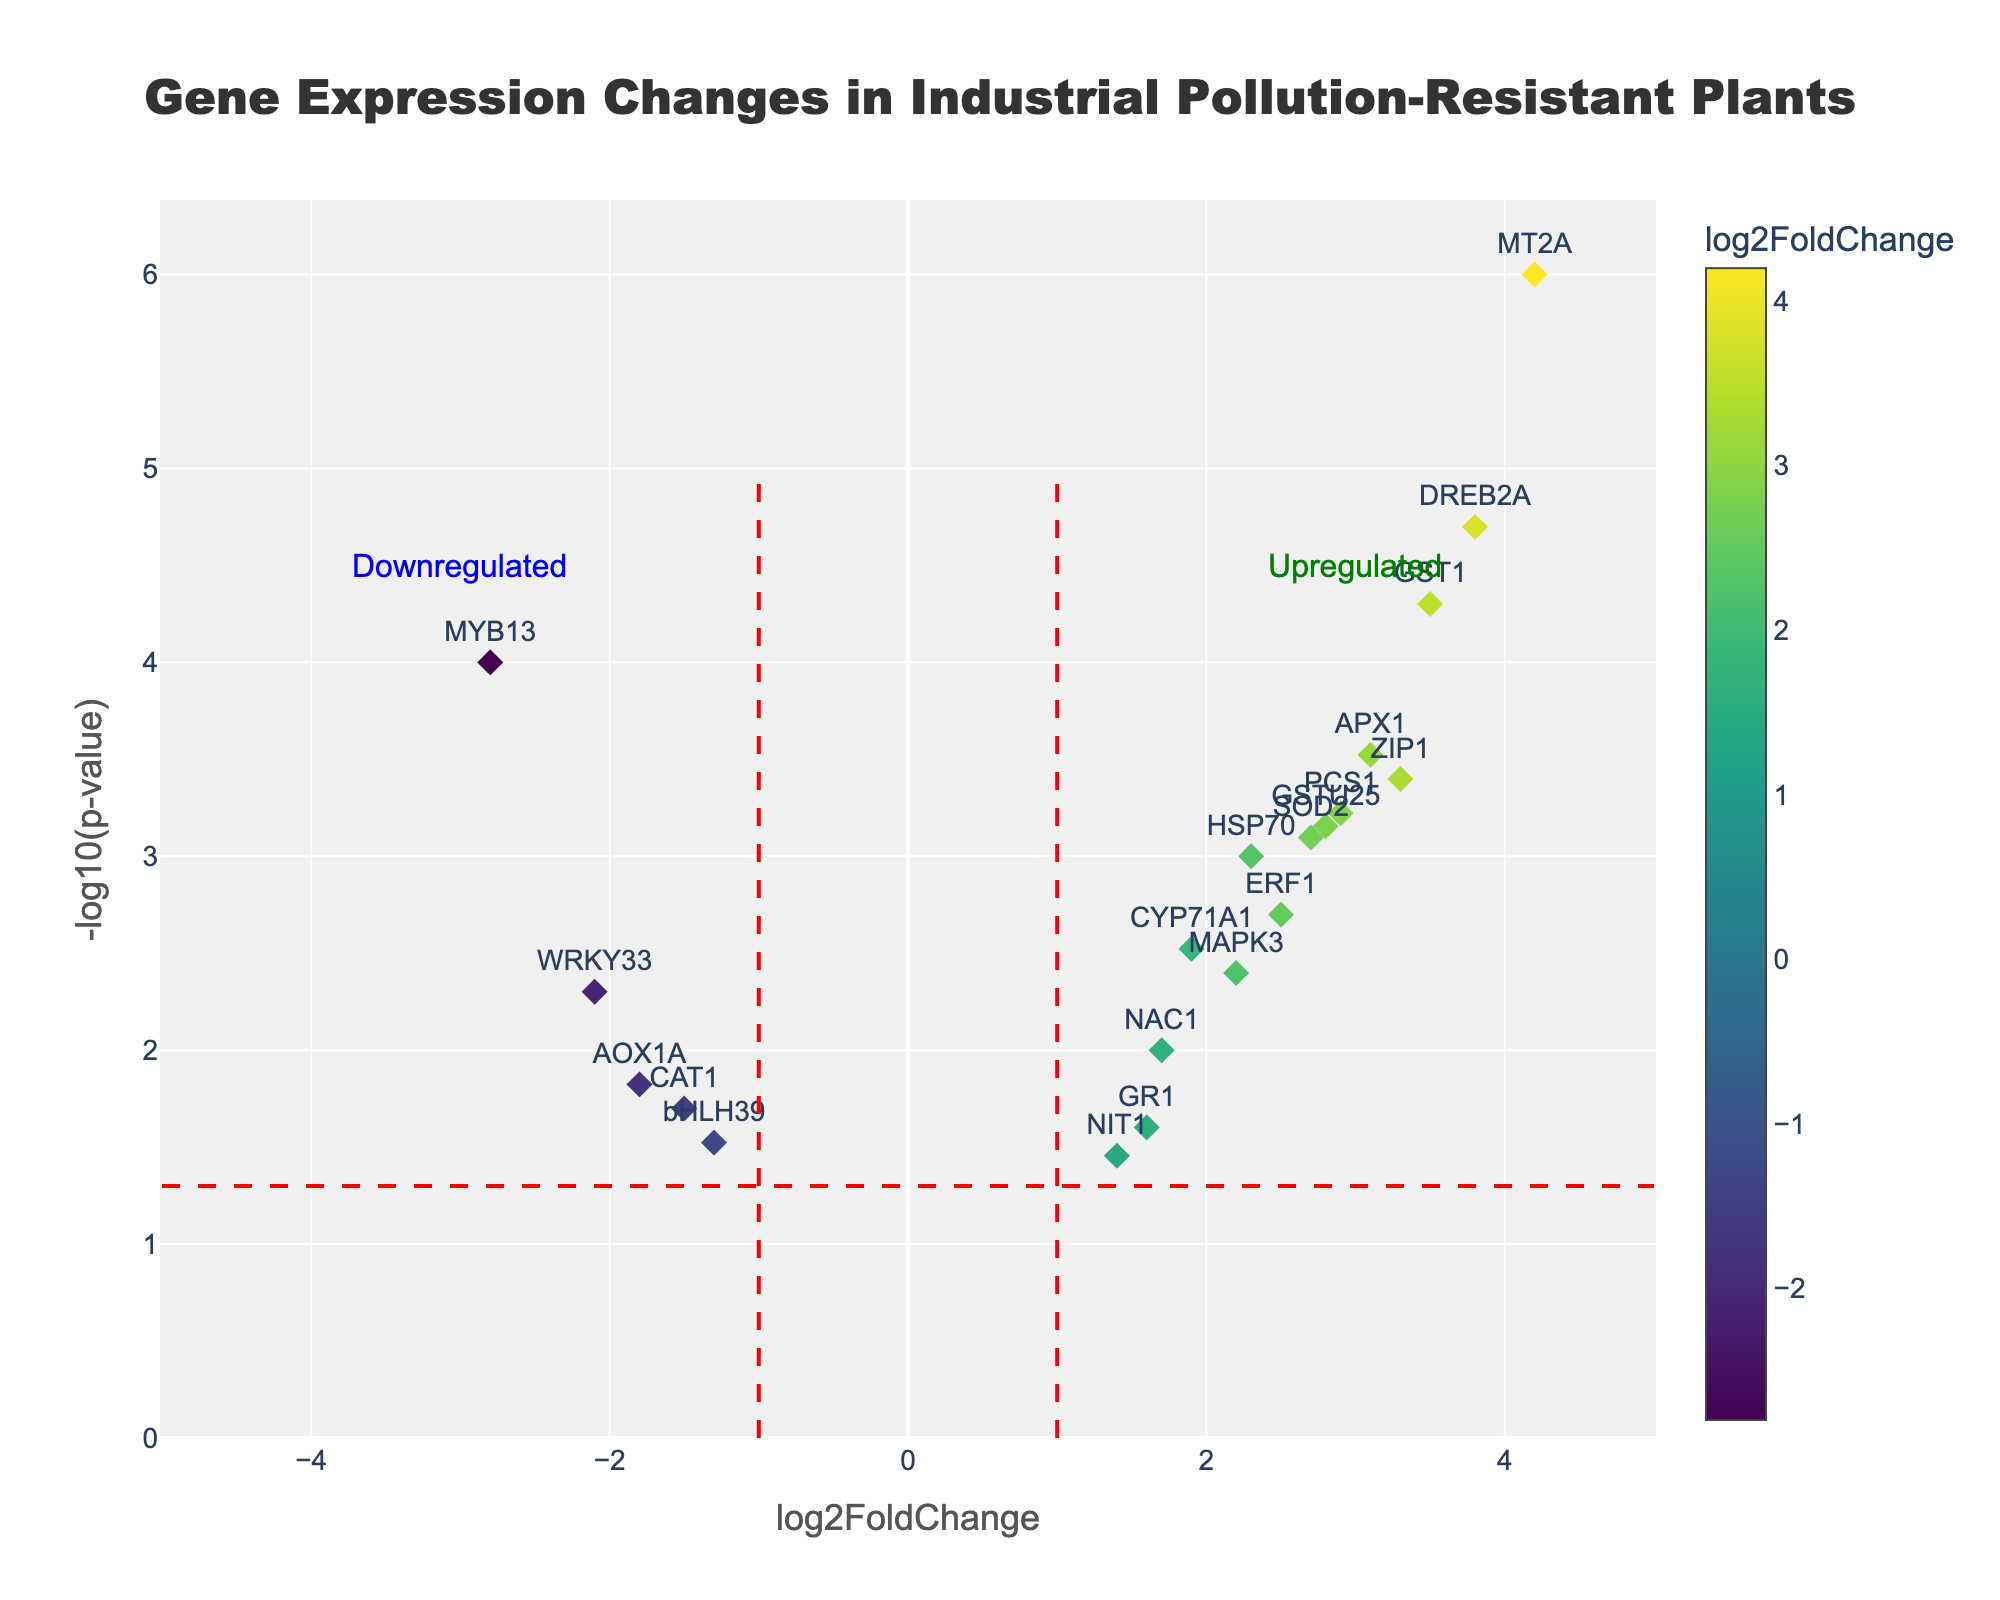What's the title of the figure? The title of the figure is displayed prominently at the top center.
Answer: Gene Expression Changes in Industrial Pollution-Resistant Plants What does the x-axis represent? The x-axis label clearly states what it represents.
Answer: log2FoldChange Which gene has the highest -log10(p-value)? Look at the y-axis and identify the gene whose marker is at the highest position.
Answer: MT2A How many genes are upregulated with a significant p-value (p < 0.05)? Upregulated genes have a positive log2FoldChange. Look for genes on the right side of x = 0 and count the ones with y > 1.3 as the significance threshold is -log10(0.05)≈1.3.
Answer: 11 Which gene is the most downregulated and what is its p-value? Look for the gene with the most negative log2FoldChange, and check its corresponding p-value.
Answer: MYB13, 0.0001 What does the red dashed vertical line at x=1 indicate? Vertical red dashed lines usually indicate thresholds. In this case, it signifies the boundary between significant downregulation and insignificant expression change for log2FoldChange = 1.
Answer: Significance threshold for upregulation Which gene shows a significant upregulation and has a log2FoldChange value close to 3.3? Look for the gene positioned near x=3.3 on the right side of the plot and check the p-value to ensure it is significant (y > 1.3).
Answer: ZIP1 Between GST1 and DREB2A, which gene has a higher fold change? Compare the log2FoldChange values of GST1 and DREB2A.
Answer: GST1 Which axis shows the significance of the gene expression changes? Identify the axis labeled with terms related to significance, e.g., p-value.
Answer: y-axis For genes with log2FoldChange > 3, what are the p-values of APX1 and MT2A? Identify genes APX1 and MT2A on the plot, then read their p-values from the hover information or data points.
Answer: 0.0003 for APX1, 0.000001 for MT2A 